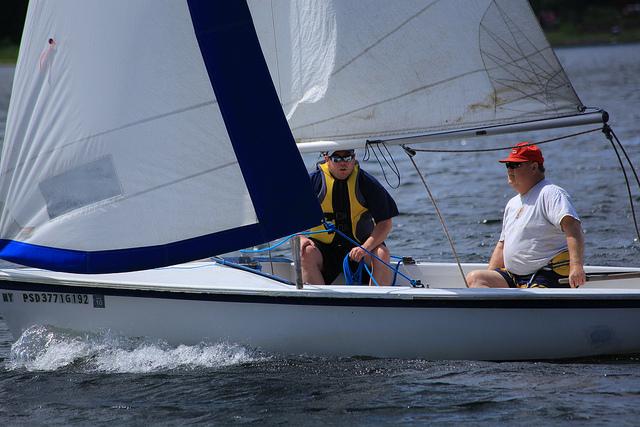What color is the life jacket?
Concise answer only. Yellow. Are they going on a sailing trip?
Keep it brief. Yes. Why is the man holding a blue rope?
Quick response, please. Sailing. 